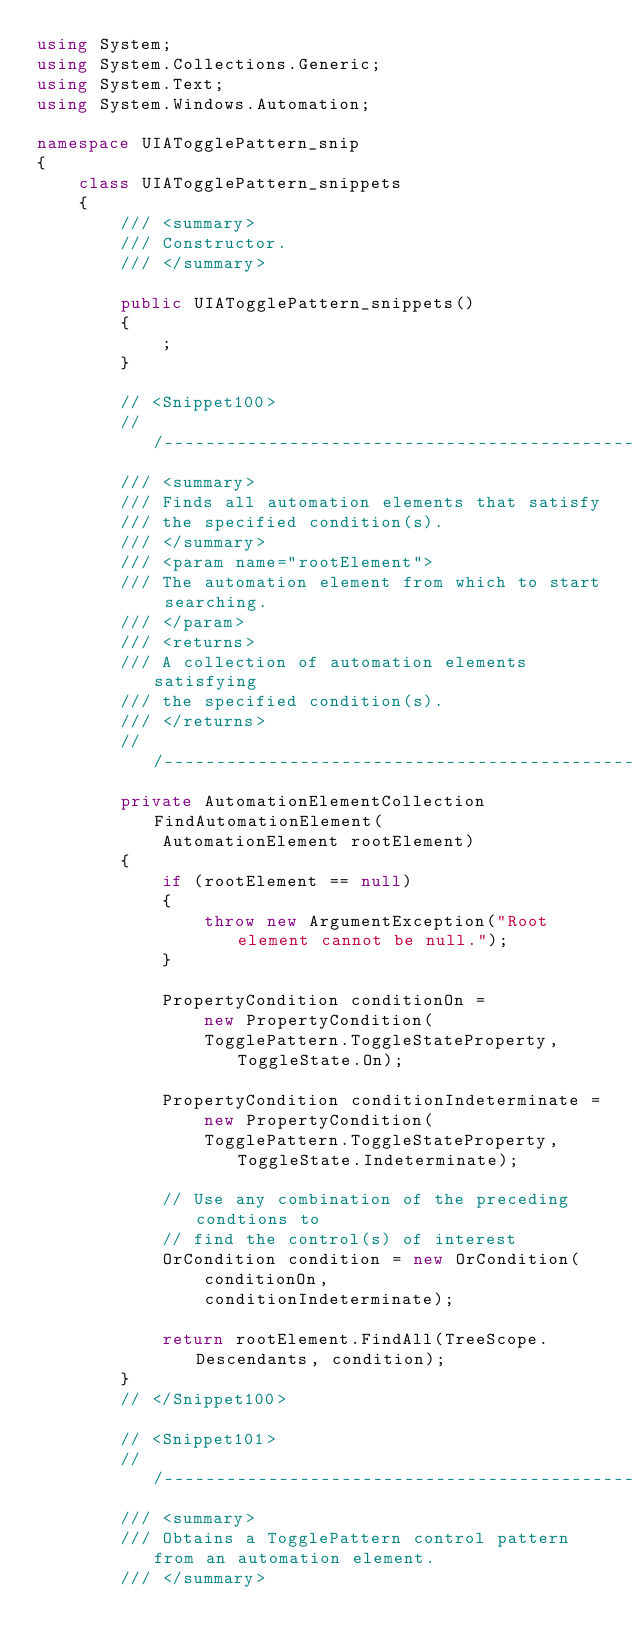Convert code to text. <code><loc_0><loc_0><loc_500><loc_500><_C#_>using System;
using System.Collections.Generic;
using System.Text;
using System.Windows.Automation;

namespace UIATogglePattern_snip
{
    class UIATogglePattern_snippets
    {
        /// <summary>
        /// Constructor.
        /// </summary>

        public UIATogglePattern_snippets()
        {
            ;
        }

        // <Snippet100>
        ///--------------------------------------------------------------------
        /// <summary>
        /// Finds all automation elements that satisfy 
        /// the specified condition(s).
        /// </summary>
        /// <param name="rootElement">
        /// The automation element from which to start searching.
        /// </param>
        /// <returns>
        /// A collection of automation elements satisfying 
        /// the specified condition(s).
        /// </returns>
        ///--------------------------------------------------------------------
        private AutomationElementCollection FindAutomationElement(
            AutomationElement rootElement)
        {
            if (rootElement == null)
            {
                throw new ArgumentException("Root element cannot be null.");
            }

            PropertyCondition conditionOn =
                new PropertyCondition(
                TogglePattern.ToggleStateProperty, ToggleState.On);

            PropertyCondition conditionIndeterminate =
                new PropertyCondition(
                TogglePattern.ToggleStateProperty, ToggleState.Indeterminate);

            // Use any combination of the preceding condtions to 
            // find the control(s) of interest
            OrCondition condition = new OrCondition(
                conditionOn,
                conditionIndeterminate);

            return rootElement.FindAll(TreeScope.Descendants, condition);
        }
        // </Snippet100>

        // <Snippet101>
        ///--------------------------------------------------------------------
        /// <summary>
        /// Obtains a TogglePattern control pattern from an automation element.
        /// </summary></code> 